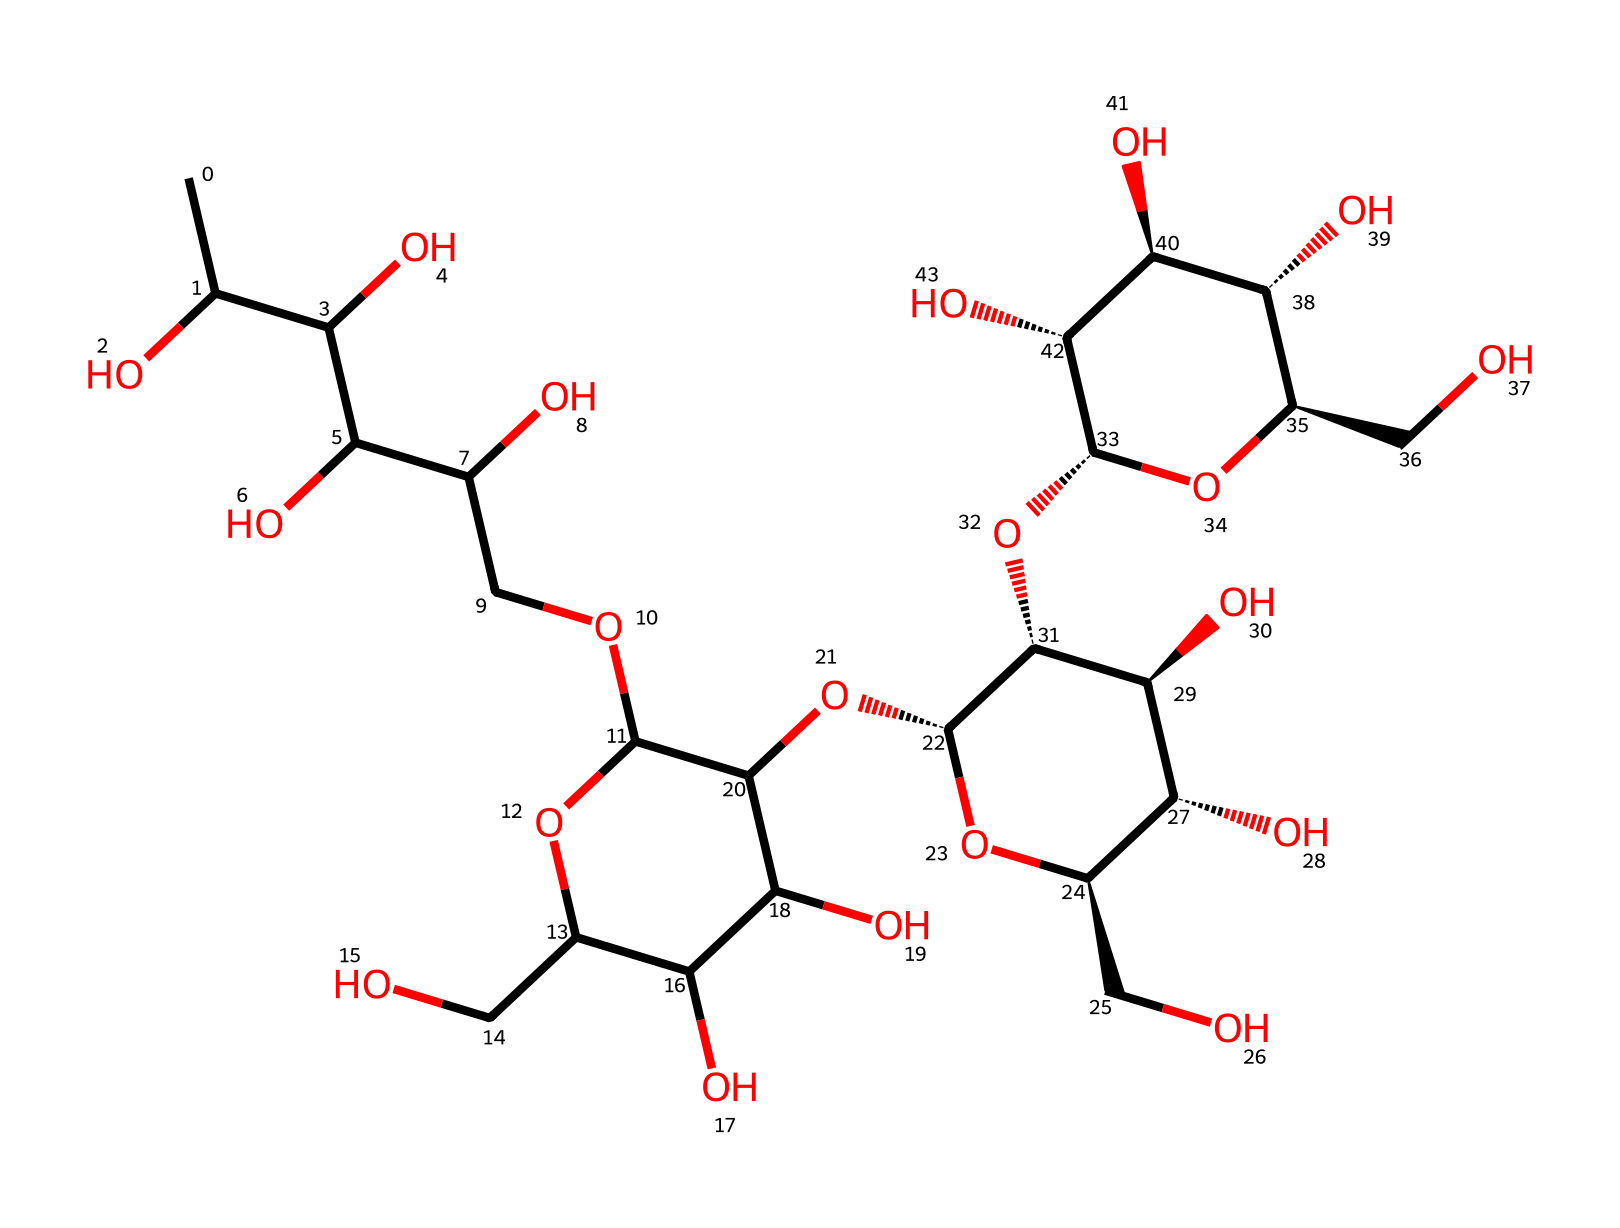What is the main component structure of acemannan? Acemannan is a polysaccharide composed primarily of mannose and its derivatives. Analyzing the SMILES shows a repetitive structure of sugar units, indicating it’s a polymer of these monosaccharides.
Answer: polysaccharide How many oxygen atoms are present in the structure? Reviewing the SMILES representation, each instance of 'O' represents an oxygen atom. By counting them, I find a total of 8 oxygen atoms present in the structure.
Answer: 8 What type of bonds are predominantly found in acemannan? The structure illustrates mainly single bonds, indicated by the absence of '=' symbols in the SMILES. This signifies that the connections between carbon and other atoms (like oxygen) are predominantly single covalent bonds.
Answer: single bonds Is acemannan branched or linear in structure? From the SMILES notation, it's evident there are branches emerging from the main chain of sugar units, particularly at certain carbon atoms, indicating that acemannan is a branched polysaccharide.
Answer: branched What sugar unit is most frequently repeated in the acemannan polymer? By analyzing the structure, I can see that mannose appears as the repeating unit throughout the polymer, as indicated by the arrangement of carbon, oxygen, and hydroxyl groups as seen in the chemical structure.
Answer: mannose How many carbon atoms are in the acemannan structure? The counting of 'C' in the SMILES representation reveals that there are 30 carbon atoms present in the acemannan polysaccharide structure.
Answer: 30 